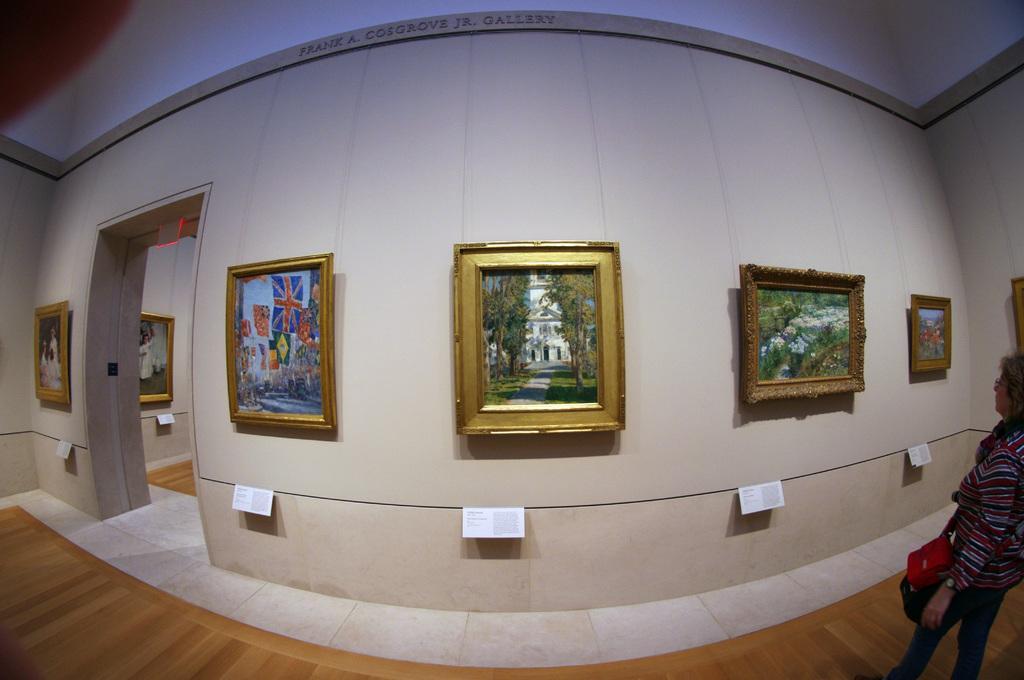Can you describe this image briefly? Pictures are on the walls. Under these pictures there are information cards. Here we can see a person. This person wore a bag. 